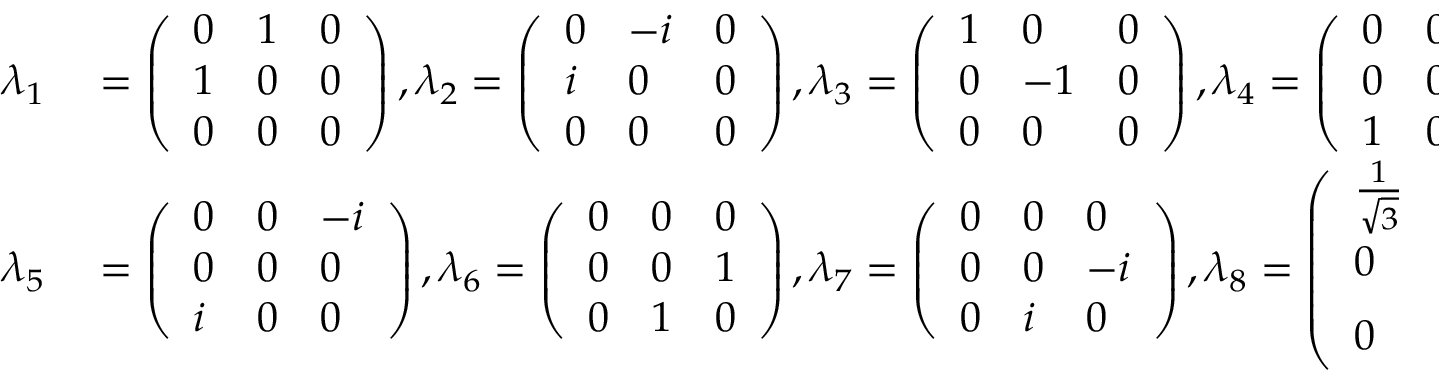Convert formula to latex. <formula><loc_0><loc_0><loc_500><loc_500>\begin{array} { r l } { \lambda _ { 1 } } & = \left ( \begin{array} { l l l } { 0 } & { 1 } & { 0 } \\ { 1 } & { 0 } & { 0 } \\ { 0 } & { 0 } & { 0 } \end{array} \right ) , \lambda _ { 2 } = \left ( \begin{array} { l l l } { 0 } & { - i } & { 0 } \\ { i } & { 0 } & { 0 } \\ { 0 } & { 0 } & { 0 } \end{array} \right ) , \lambda _ { 3 } = \left ( \begin{array} { l l l } { 1 } & { 0 } & { 0 } \\ { 0 } & { - 1 } & { 0 } \\ { 0 } & { 0 } & { 0 } \end{array} \right ) , \lambda _ { 4 } = \left ( \begin{array} { l l l } { 0 } & { 0 } & { 1 } \\ { 0 } & { 0 } & { 0 } \\ { 1 } & { 0 } & { 0 } \end{array} \right ) , } \\ { \lambda _ { 5 } } & = \left ( \begin{array} { l l l } { 0 } & { 0 } & { - i } \\ { 0 } & { 0 } & { 0 } \\ { i } & { 0 } & { 0 } \end{array} \right ) , \lambda _ { 6 } = \left ( \begin{array} { l l l } { 0 } & { 0 } & { 0 } \\ { 0 } & { 0 } & { 1 } \\ { 0 } & { 1 } & { 0 } \end{array} \right ) , \lambda _ { 7 } = \left ( \begin{array} { l l l } { 0 } & { 0 } & { 0 } \\ { 0 } & { 0 } & { - i } \\ { 0 } & { i } & { 0 } \end{array} \right ) , \lambda _ { 8 } = \left ( \begin{array} { l l l } { \frac { 1 } { \sqrt { 3 } } } & { 0 } & { 0 } \\ { 0 } & { \frac { 1 } { \sqrt { 3 } } } & { 0 } \\ { 0 } & { 0 } & { \frac { - 2 } { \sqrt { 3 } } } \end{array} \right ) . } \end{array}</formula> 